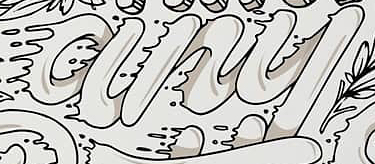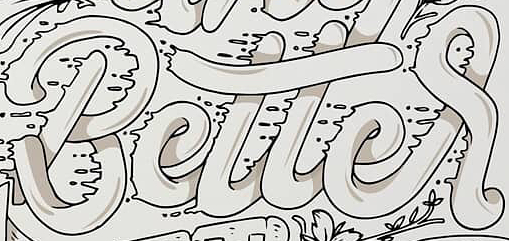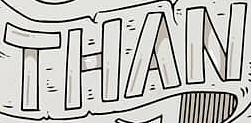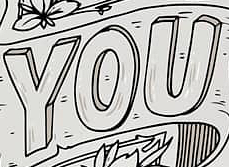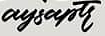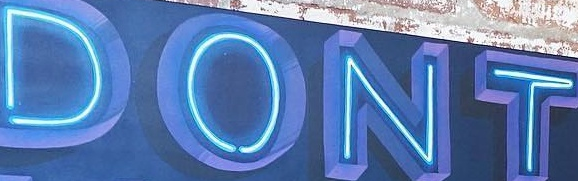What words can you see in these images in sequence, separated by a semicolon? any; Better; THAN; YOU; aysaptr; DONT 